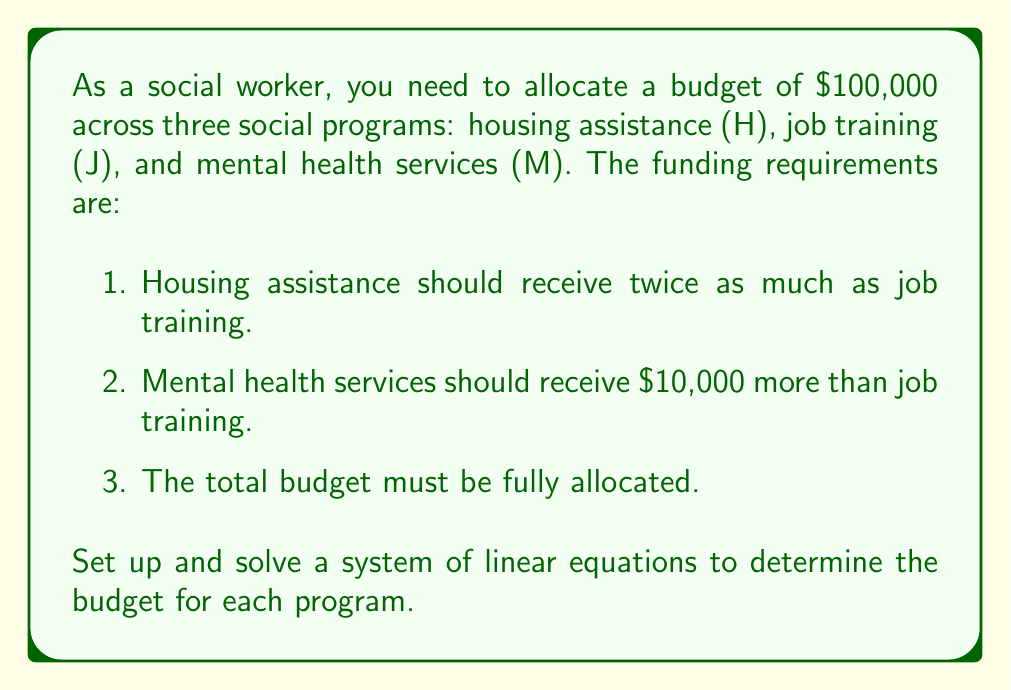Show me your answer to this math problem. Let's approach this step-by-step:

1) First, let's define our variables:
   H = Housing assistance budget
   J = Job training budget
   M = Mental health services budget

2) Now, we can set up our equations based on the given conditions:
   
   Equation 1: $H = 2J$ (Housing gets twice as much as job training)
   Equation 2: $M = J + 10000$ (Mental health gets $10,000 more than job training)
   Equation 3: $H + J + M = 100000$ (Total budget allocation)

3) Let's substitute the expressions for H and M from equations 1 and 2 into equation 3:

   $2J + J + (J + 10000) = 100000$

4) Simplify:

   $4J + 10000 = 100000$

5) Subtract 10000 from both sides:

   $4J = 90000$

6) Divide both sides by 4:

   $J = 22500$

7) Now that we know J, we can find H and M:

   $H = 2J = 2(22500) = 45000$
   $M = J + 10000 = 22500 + 10000 = 32500$

8) Let's verify that these values satisfy all conditions:
   - H is twice J: $45000 = 2(22500)$ ✓
   - M is $10,000 more than J: $32500 = 22500 + 10000$ ✓
   - Total budget: $45000 + 22500 + 32500 = 100000$ ✓

Therefore, the budget allocations are:
Housing assistance: $45,000
Job training: $22,500
Mental health services: $32,500
Answer: H = $45,000, J = $22,500, M = $32,500 